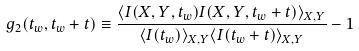Convert formula to latex. <formula><loc_0><loc_0><loc_500><loc_500>g _ { 2 } ( t _ { w } , t _ { w } + t ) \equiv \frac { \langle I ( X , Y , t _ { w } ) I ( X , Y , t _ { w } + t ) \rangle _ { X , Y } } { \langle I ( t _ { w } ) \rangle _ { X , Y } \langle I ( t _ { w } + t ) \rangle _ { X , Y } } - 1</formula> 